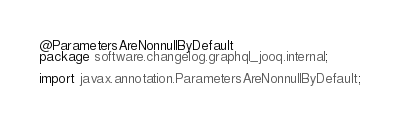<code> <loc_0><loc_0><loc_500><loc_500><_Java_>@ParametersAreNonnullByDefault
package software.changelog.graphql_jooq.internal;

import javax.annotation.ParametersAreNonnullByDefault;
</code> 